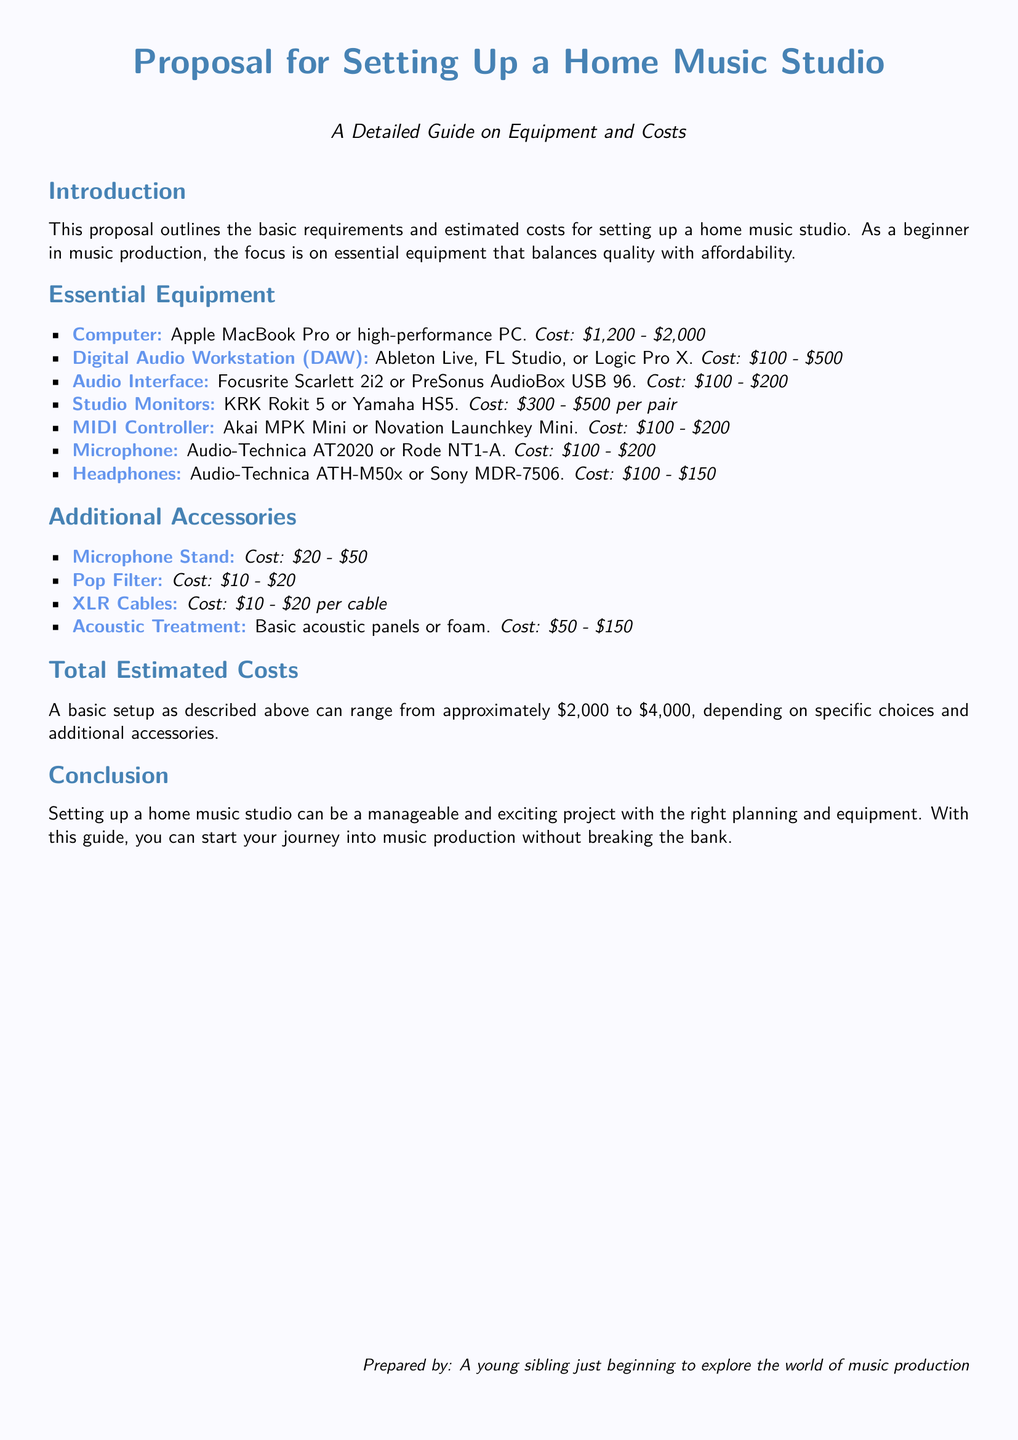What is the focus of this proposal? The proposal outlines the basic requirements and estimated costs for setting up a home music studio, emphasizing essential equipment that balances quality with affordability.
Answer: Setting up a home music studio What is the cost range for a computer? The proposal provides a cost range for a computer as part of essential equipment for the studio setup.
Answer: $1,200 - $2,000 Which DAWs are suggested? The proposal lists specific Digital Audio Workstations recommended for the music studio setup.
Answer: Ableton Live, FL Studio, Logic Pro X What is the estimated total cost range for a basic setup? The proposal summarizes the costs of the equipment and accessories to provide an overall estimated cost range.
Answer: $2,000 to $4,000 What type of headphones is mentioned? The proposal includes specific examples of headphones suitable for the studio setup.
Answer: Audio-Technica ATH-M50x, Sony MDR-7506 How many accessories are listed in the document? The proposal includes a section on additional accessories for the studio, which can be counted for a total.
Answer: Four accessories What is the purpose of the acoustic treatment mentioned? The proposal briefly discusses the need for acoustic treatment in the context of a home music studio.
Answer: Basic acoustic panels or foam What is highlighted in the conclusion? The conclusion emphasizes the overall message and outcome for setting up a home music studio.
Answer: Exciting project with right planning and equipment 